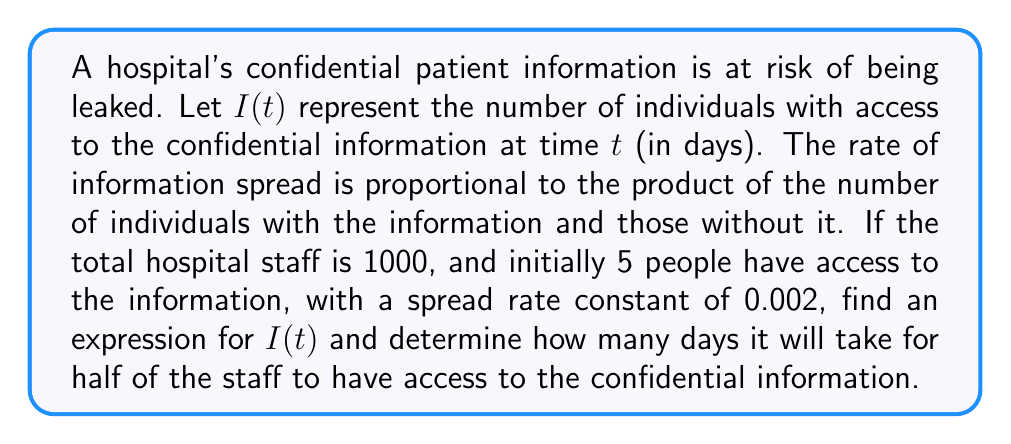What is the answer to this math problem? 1) First, let's set up the differential equation:
   $$\frac{dI}{dt} = kI(1000-I)$$
   where $k = 0.002$ is the spread rate constant.

2) This is a logistic differential equation. The solution is given by:
   $$I(t) = \frac{1000}{1 + Ce^{-1000kt}}$$
   where $C$ is a constant to be determined.

3) We know that initially, $I(0) = 5$. Let's use this to find $C$:
   $$5 = \frac{1000}{1 + C}$$
   $$C = \frac{1000}{5} - 1 = 199$$

4) So our solution is:
   $$I(t) = \frac{1000}{1 + 199e^{-2t}}$$

5) To find when half the staff has access, we solve:
   $$500 = \frac{1000}{1 + 199e^{-2t}}$$

6) Simplifying:
   $$1 + 199e^{-2t} = 2$$
   $$199e^{-2t} = 1$$
   $$e^{-2t} = \frac{1}{199}$$

7) Taking natural log of both sides:
   $$-2t = \ln(\frac{1}{199}) = -\ln(199)$$

8) Solving for $t$:
   $$t = \frac{\ln(199)}{2} \approx 2.65$$

Therefore, it will take approximately 2.65 days for half of the staff to have access to the confidential information.
Answer: $I(t) = \frac{1000}{1 + 199e^{-2t}}$; 2.65 days 